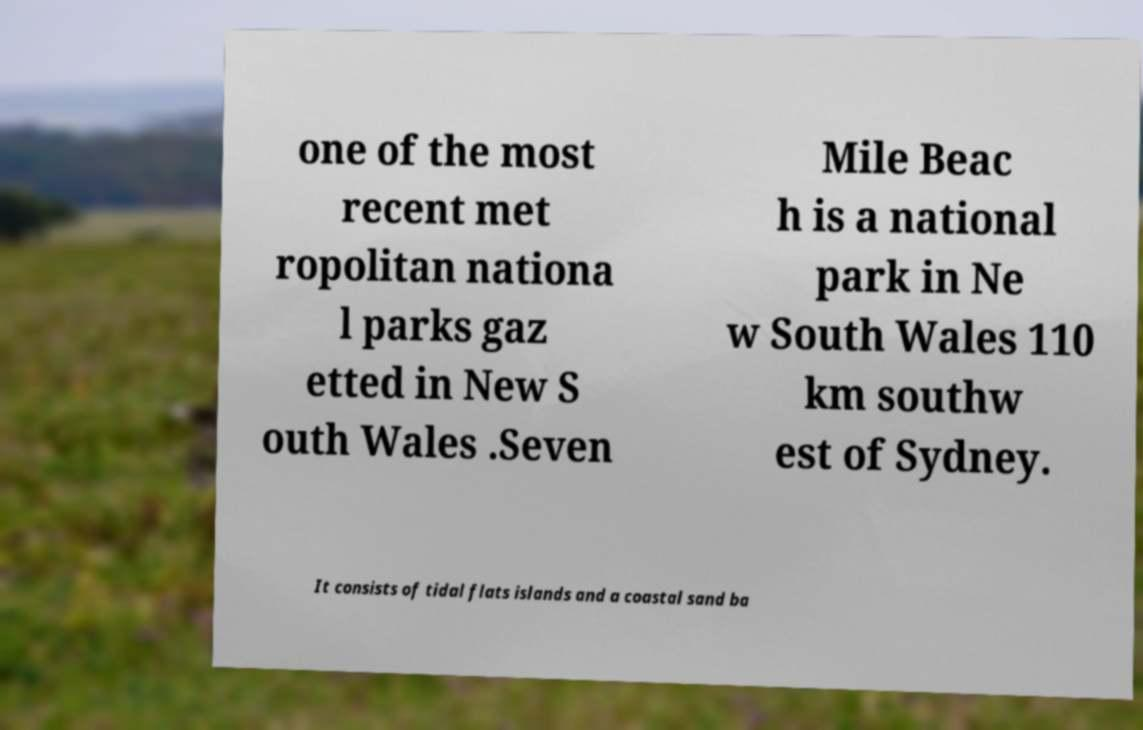For documentation purposes, I need the text within this image transcribed. Could you provide that? one of the most recent met ropolitan nationa l parks gaz etted in New S outh Wales .Seven Mile Beac h is a national park in Ne w South Wales 110 km southw est of Sydney. It consists of tidal flats islands and a coastal sand ba 